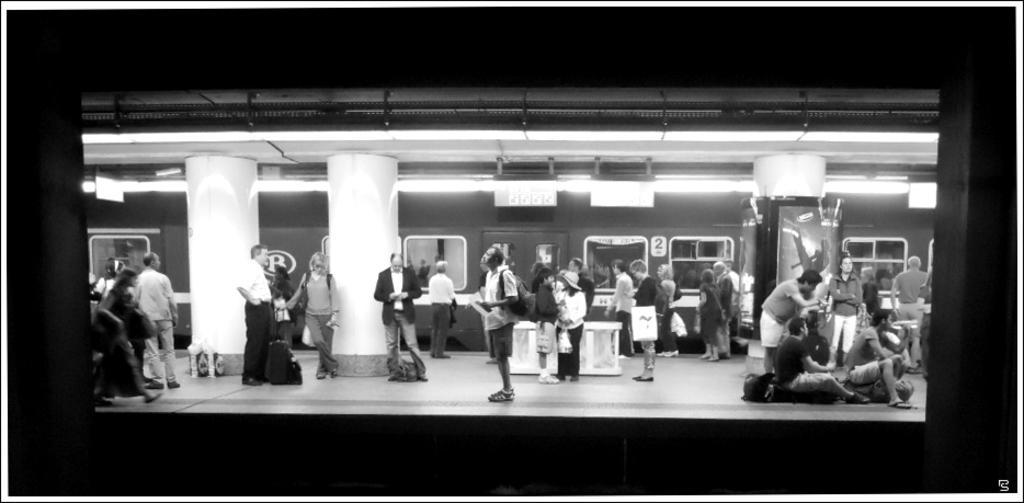Please provide a concise description of this image. In the picture we can see a railway station image with a station under it we can see some people are standing with luggage and bags and some people are sitting near the pillars and behind it, we can see a train with windows and glasses to it, and to the ceiling of the station we can see the lights. 